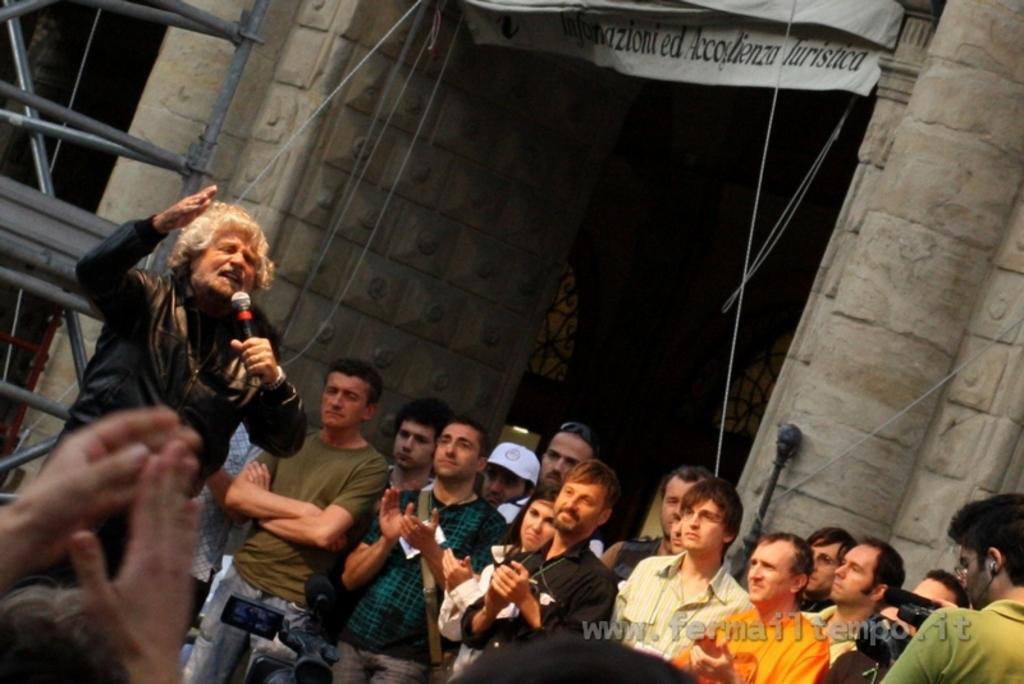Describe this image in one or two sentences. In this image I can see the group of people with different color dresses. I can see one person is wearing the cap. I can one person is holding the mic and an another person holding the camera. In the background I can see the banner to the building. To the left I can see the metal rod. 